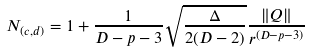<formula> <loc_0><loc_0><loc_500><loc_500>N _ { ( c , d ) } = 1 + \frac { 1 } { D - p - 3 } \sqrt { \frac { \Delta } { 2 ( D - 2 ) } } \frac { \| Q \| } { r ^ { ( D - p - 3 ) } }</formula> 